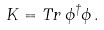Convert formula to latex. <formula><loc_0><loc_0><loc_500><loc_500>K = T r \, \phi ^ { \dagger } \phi \, .</formula> 